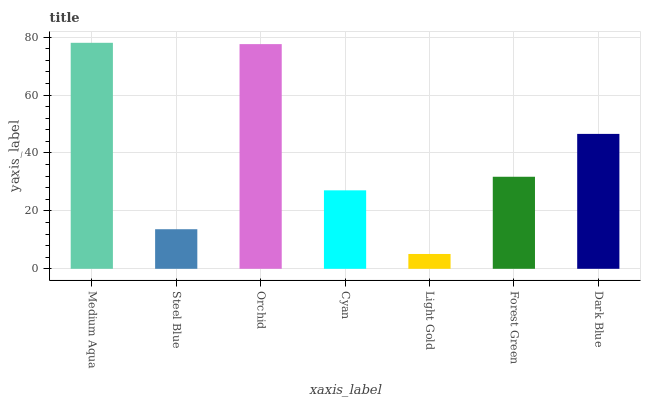Is Steel Blue the minimum?
Answer yes or no. No. Is Steel Blue the maximum?
Answer yes or no. No. Is Medium Aqua greater than Steel Blue?
Answer yes or no. Yes. Is Steel Blue less than Medium Aqua?
Answer yes or no. Yes. Is Steel Blue greater than Medium Aqua?
Answer yes or no. No. Is Medium Aqua less than Steel Blue?
Answer yes or no. No. Is Forest Green the high median?
Answer yes or no. Yes. Is Forest Green the low median?
Answer yes or no. Yes. Is Light Gold the high median?
Answer yes or no. No. Is Cyan the low median?
Answer yes or no. No. 